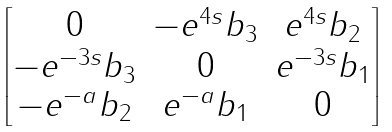<formula> <loc_0><loc_0><loc_500><loc_500>\begin{bmatrix} 0 & - e ^ { 4 s } b _ { 3 } & e ^ { 4 s } b _ { 2 } \\ - e ^ { - 3 s } b _ { 3 } & 0 & e ^ { - 3 s } b _ { 1 } \\ - e ^ { - a } b _ { 2 } & e ^ { - a } b _ { 1 } & 0 \end{bmatrix}</formula> 